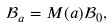Convert formula to latex. <formula><loc_0><loc_0><loc_500><loc_500>\mathcal { B } _ { a } = M ( a ) \mathcal { B } _ { 0 } ,</formula> 